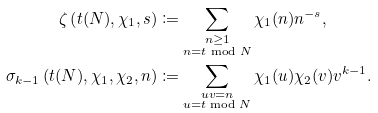<formula> <loc_0><loc_0><loc_500><loc_500>\zeta \left ( t ( N ) , \chi _ { 1 } , s \right ) & \coloneqq \sum _ { \substack { n \geq 1 \\ n = t \bmod N } } \chi _ { 1 } ( n ) n ^ { - s } , \\ \sigma _ { k - 1 } \left ( t ( N ) , \chi _ { 1 } , \chi _ { 2 } , n \right ) & \coloneqq \sum _ { \substack { u v = n \\ u = t \bmod N } } \chi _ { 1 } ( u ) \chi _ { 2 } ( v ) v ^ { k - 1 } .</formula> 